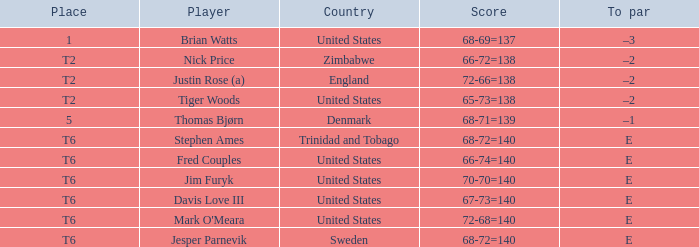The player for which country had a score of 66-72=138? Zimbabwe. 